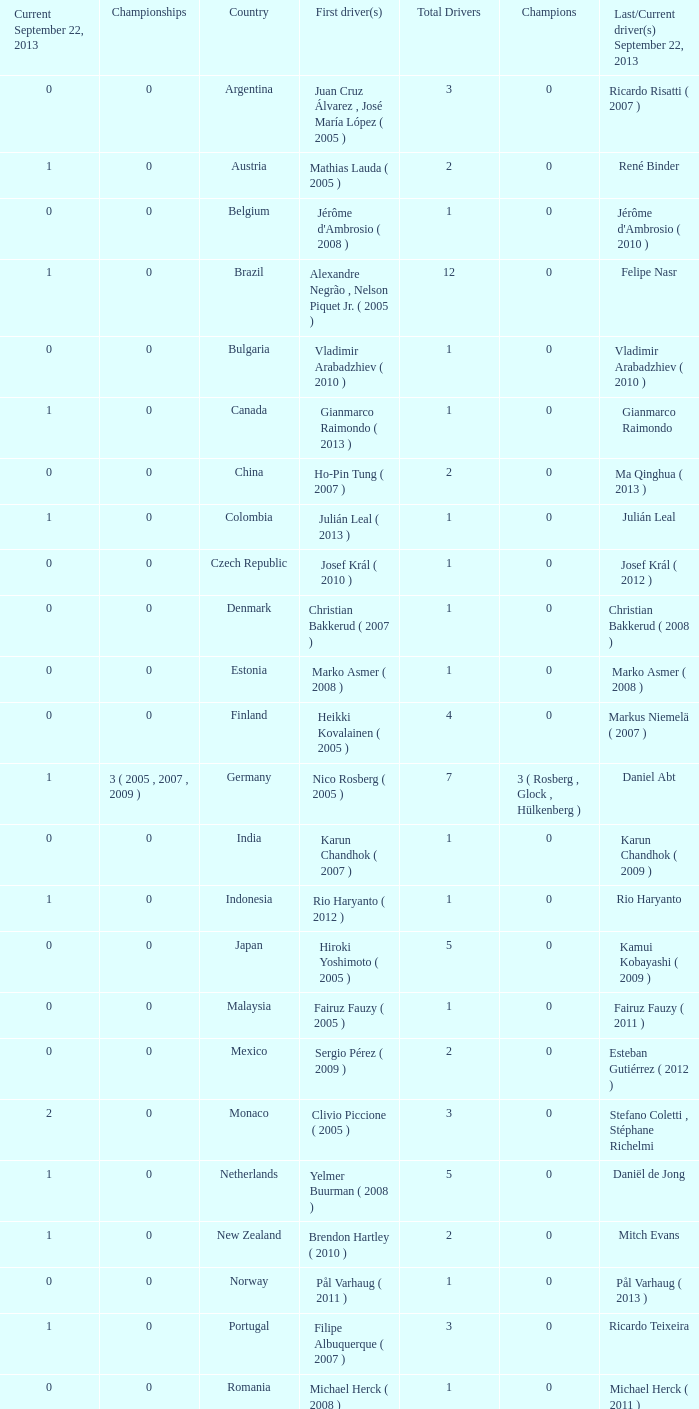How many champions were there when the first driver was hiroki yoshimoto ( 2005 )? 0.0. 